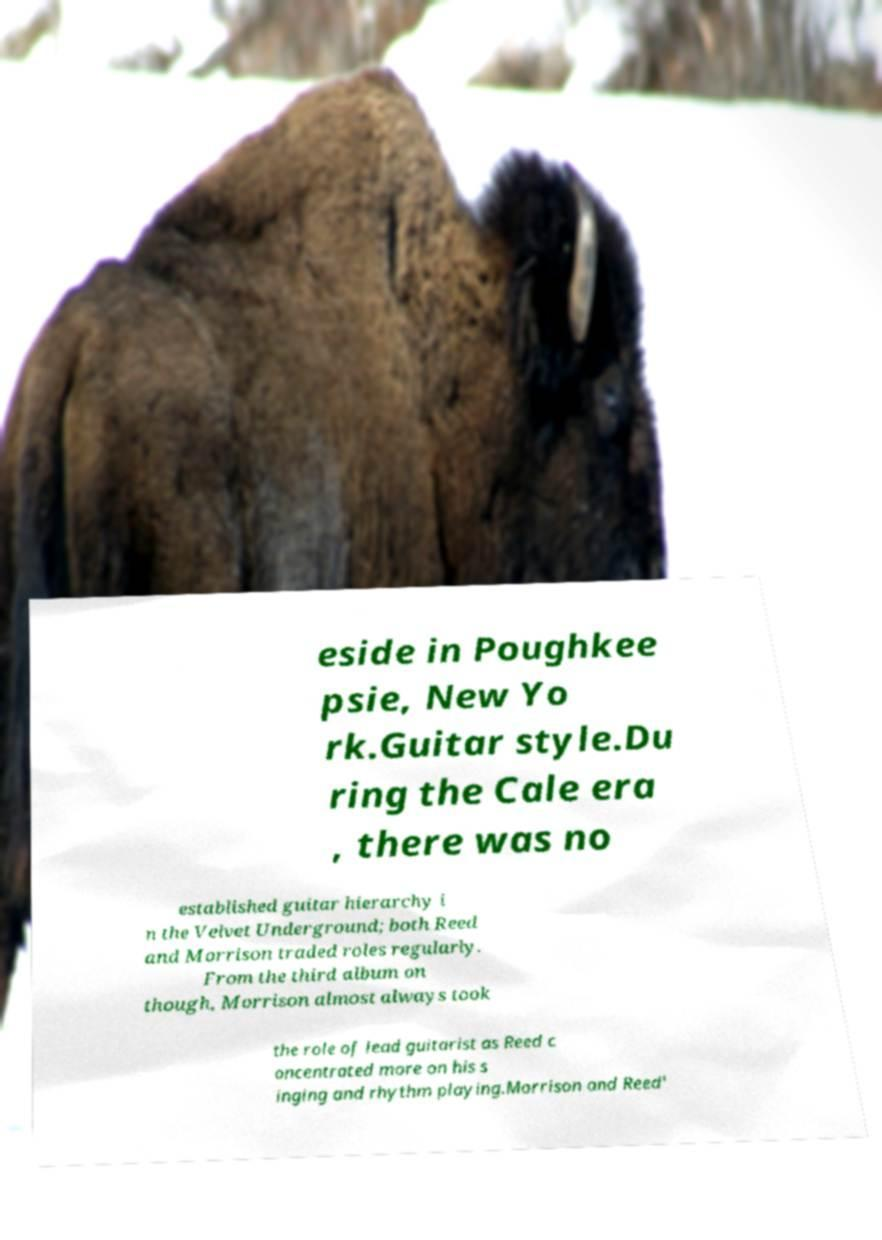I need the written content from this picture converted into text. Can you do that? eside in Poughkee psie, New Yo rk.Guitar style.Du ring the Cale era , there was no established guitar hierarchy i n the Velvet Underground; both Reed and Morrison traded roles regularly. From the third album on though, Morrison almost always took the role of lead guitarist as Reed c oncentrated more on his s inging and rhythm playing.Morrison and Reed' 